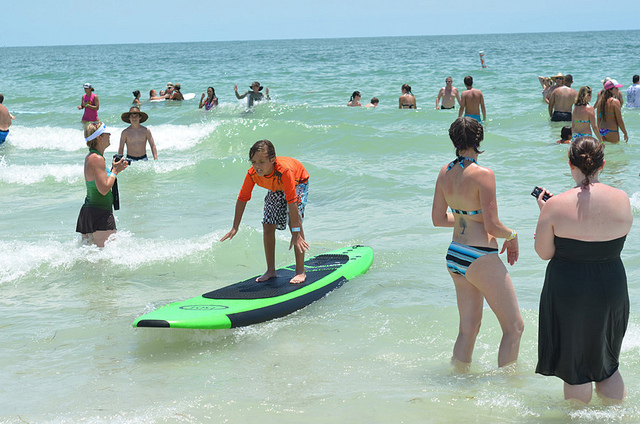Are these people in a swimming pool? No, they are in the ocean. 